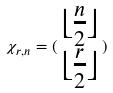Convert formula to latex. <formula><loc_0><loc_0><loc_500><loc_500>\chi _ { r , n } = ( \begin{matrix} \lfloor \frac { n } { 2 } \rfloor \\ \lfloor \frac { r } { 2 } \rfloor \end{matrix} )</formula> 